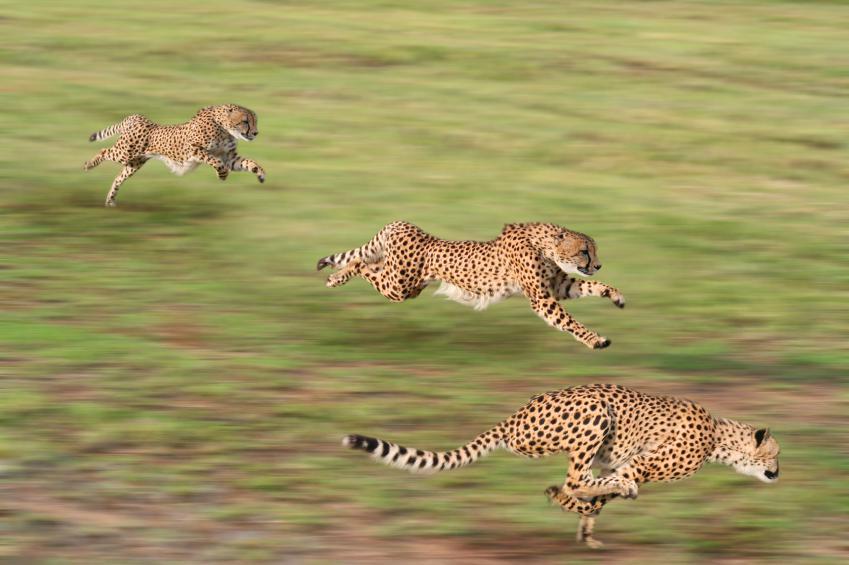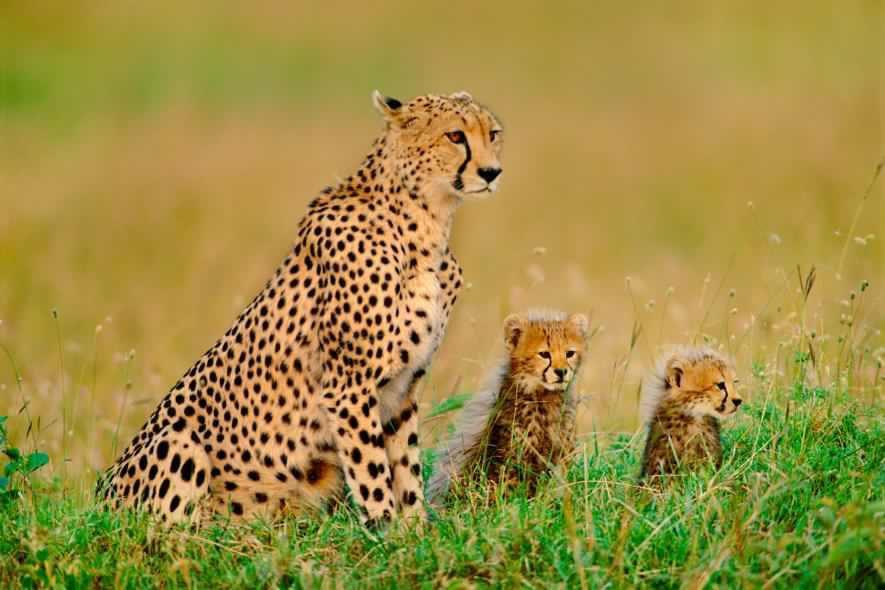The first image is the image on the left, the second image is the image on the right. For the images displayed, is the sentence "A single cheetah is leaping in the air in the left image." factually correct? Answer yes or no. No. The first image is the image on the left, the second image is the image on the right. For the images shown, is this caption "There is a mother cheetah sitting and watching as her 3 cubs are close to her" true? Answer yes or no. No. 